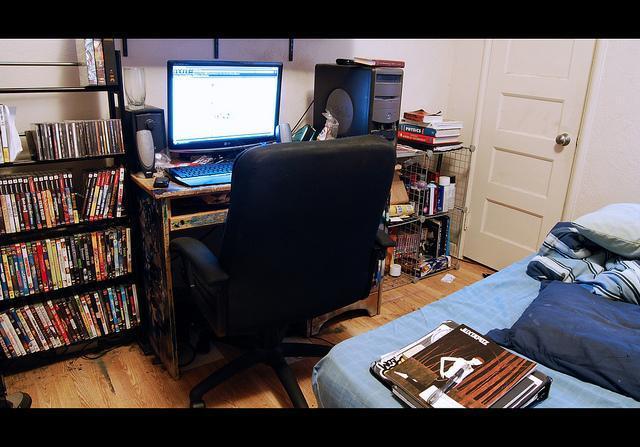How many books can you see?
Give a very brief answer. 3. 